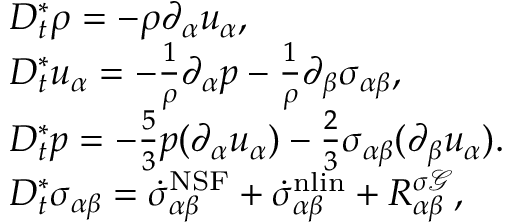Convert formula to latex. <formula><loc_0><loc_0><loc_500><loc_500>\begin{array} { r l } & { D _ { t } ^ { * } \rho = - \rho \partial _ { \alpha } u _ { \alpha } , } \\ & { D _ { t } ^ { * } u _ { \alpha } = - \frac { 1 } { \rho } \partial _ { \alpha } p - \frac { 1 } { \rho } \partial _ { \beta } { \sigma } _ { \alpha \beta } , } \\ & { D _ { t } ^ { * } p = - \frac { 5 } { 3 } p ( \partial _ { \alpha } u _ { \alpha } ) - \frac { 2 } { 3 } \sigma _ { \alpha \beta } ( \partial _ { \beta } u _ { \alpha } ) . } \\ & { D _ { t } ^ { * } \sigma _ { \alpha \beta } = \dot { \sigma } _ { \alpha \beta } ^ { N S F } + \dot { \sigma } _ { \alpha \beta } ^ { n l i n } + R _ { \alpha \beta } ^ { \sigma \mathcal { G } } , } \end{array}</formula> 